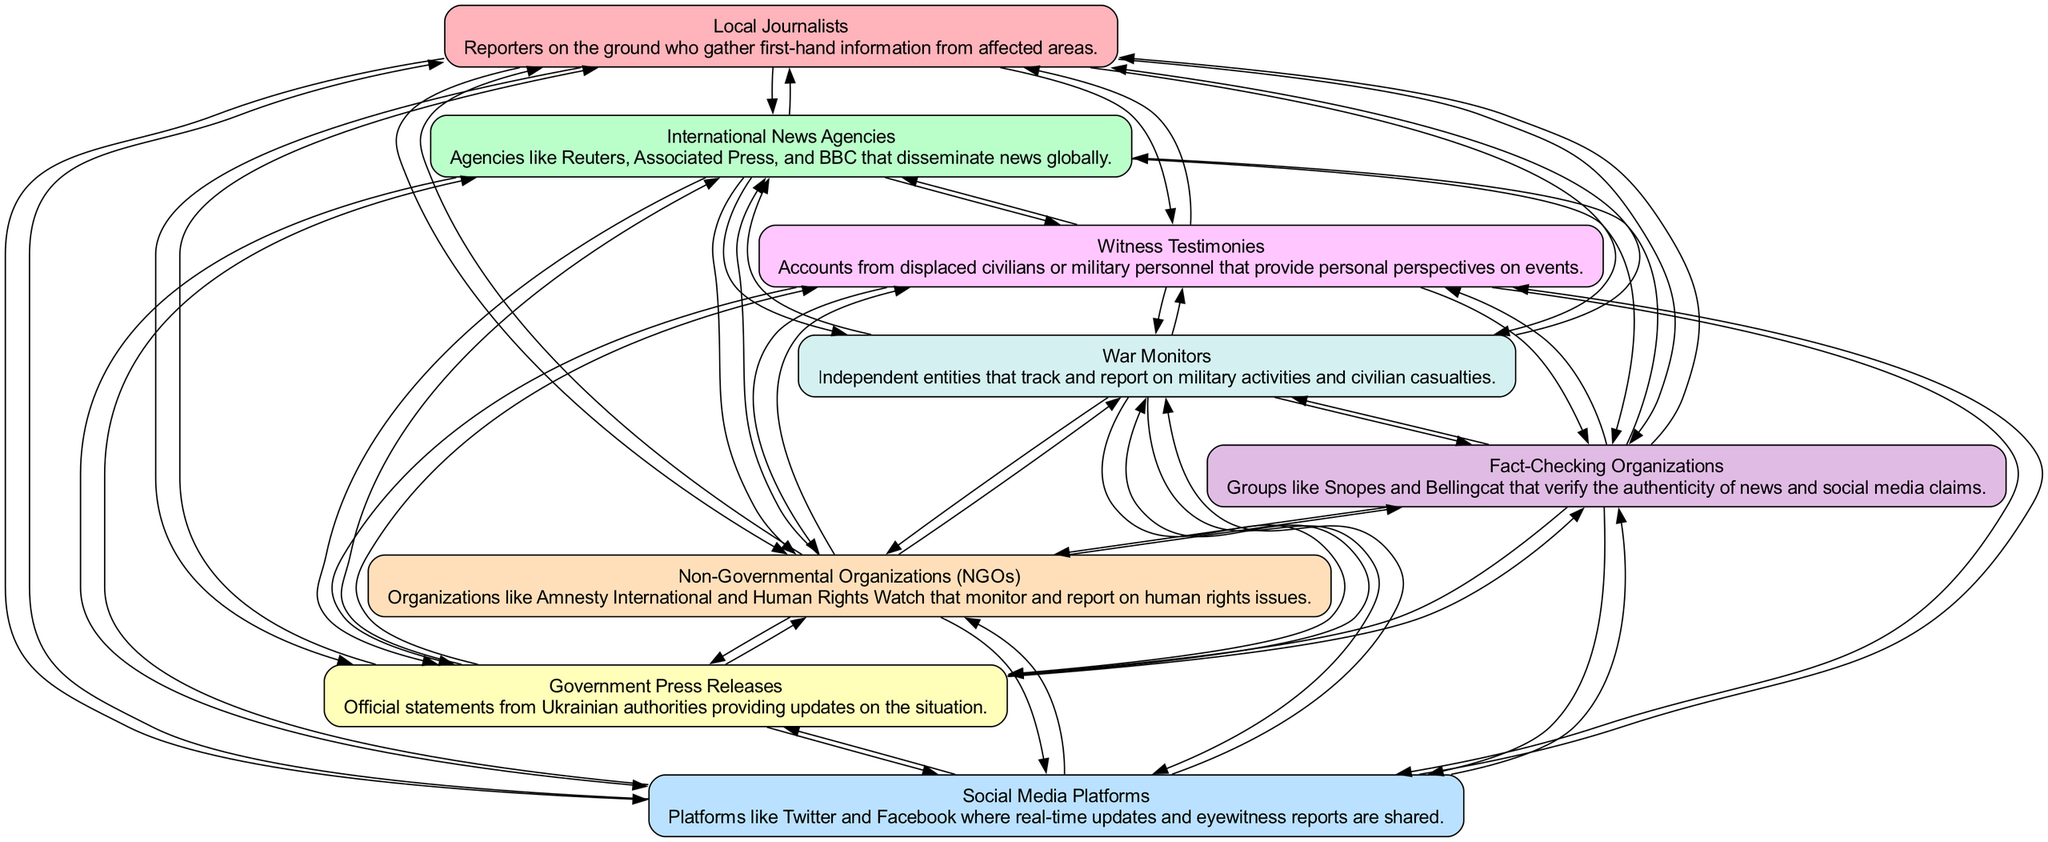What are the sources of news in the diagram? The diagram lists the following sources: Local Journalists, International News Agencies, Social Media Platforms, Government Press Releases, Non-Governmental Organizations, Fact-Checking Organizations, War Monitors, and Witness Testimonies. These nodes represent the various entities that contribute to the flow of crisis information.
Answer: Local Journalists, International News Agencies, Social Media Platforms, Government Press Releases, Non-Governmental Organizations, Fact-Checking Organizations, War Monitors, Witness Testimonies How many nodes are in the diagram? The diagram includes eight nodes, representing different sources and methods of obtaining crisis information. This can be counted directly from the elements listed in the diagram.
Answer: Eight Which node has the description of "Official statements from Ukrainian authorities providing updates on the situation"? This description corresponds to the node labeled "Government Press Releases." Each node includes a summary of the various sources, and this one specifically identifies the type of official communication from authorities.
Answer: Government Press Releases What is the relationship between Local Journalists and War Monitors? The arrows indicate that Local Journalists provide information to War Monitors, suggesting a flow of information from those on the ground to independent entities tracking military activities and civilian casualties.
Answer: Local Journalists inform War Monitors Which type of organization is responsible for verifying the authenticity of news and social media claims? The node labeled "Fact-Checking Organizations" specifies this role; these groups work to confirm the reliability of the information shared across various platforms.
Answer: Fact-Checking Organizations How many edges connect the node "Social Media Platforms" to other nodes? Looking at the connectivity of the node "Social Media Platforms" in the diagram, it has directed edges that connect to multiple nodes, indicating its role in disseminating real-time updates to various entities. This accounts for seven edges connecting to other nodes.
Answer: Seven Which organization specifically monitors human rights issues in the context of the diagram? The node labeled "Non-Governmental Organizations" is tasked with this responsibility, highlighting their role in observing and reporting on human rights conditions amid the crisis.
Answer: Non-Governmental Organizations Which nodes provide eyewitness accounts according to the diagram? The diagram shows that "Witness Testimonies" is the node that represents firsthand accounts from civilians and military personnel, emphasizing personal perspectives on events during the crisis.
Answer: Witness Testimonies How does information flow from international entities to local sources? Information flows from "International News Agencies" to other nodes including "Social Media Platforms" and "Local Journalists," suggesting that international reporting influences local narratives while disseminating information on a global scale.
Answer: International News Agencies influence Local Journalists and Social Media Platforms 